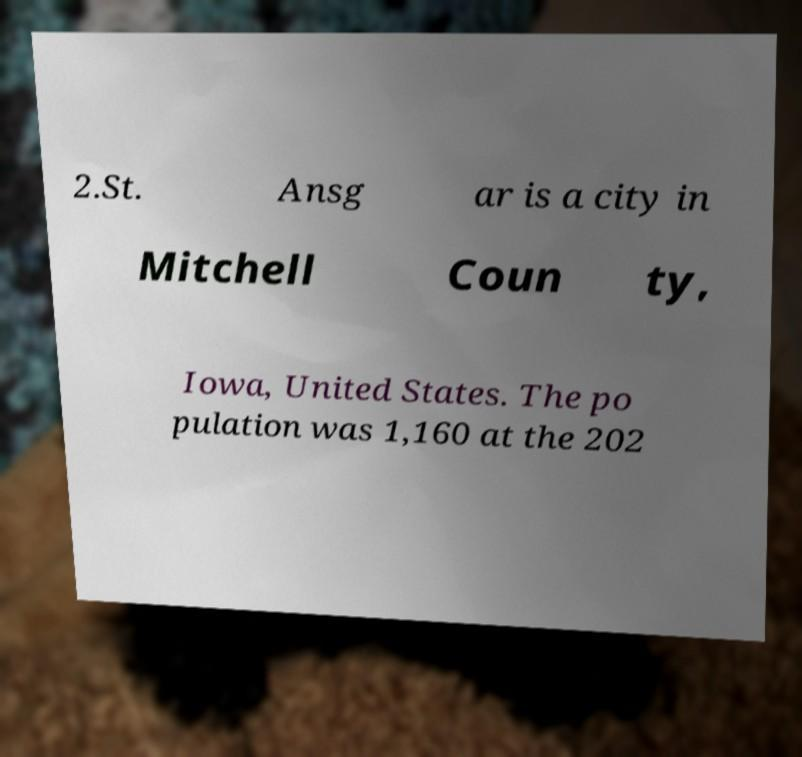Could you assist in decoding the text presented in this image and type it out clearly? 2.St. Ansg ar is a city in Mitchell Coun ty, Iowa, United States. The po pulation was 1,160 at the 202 